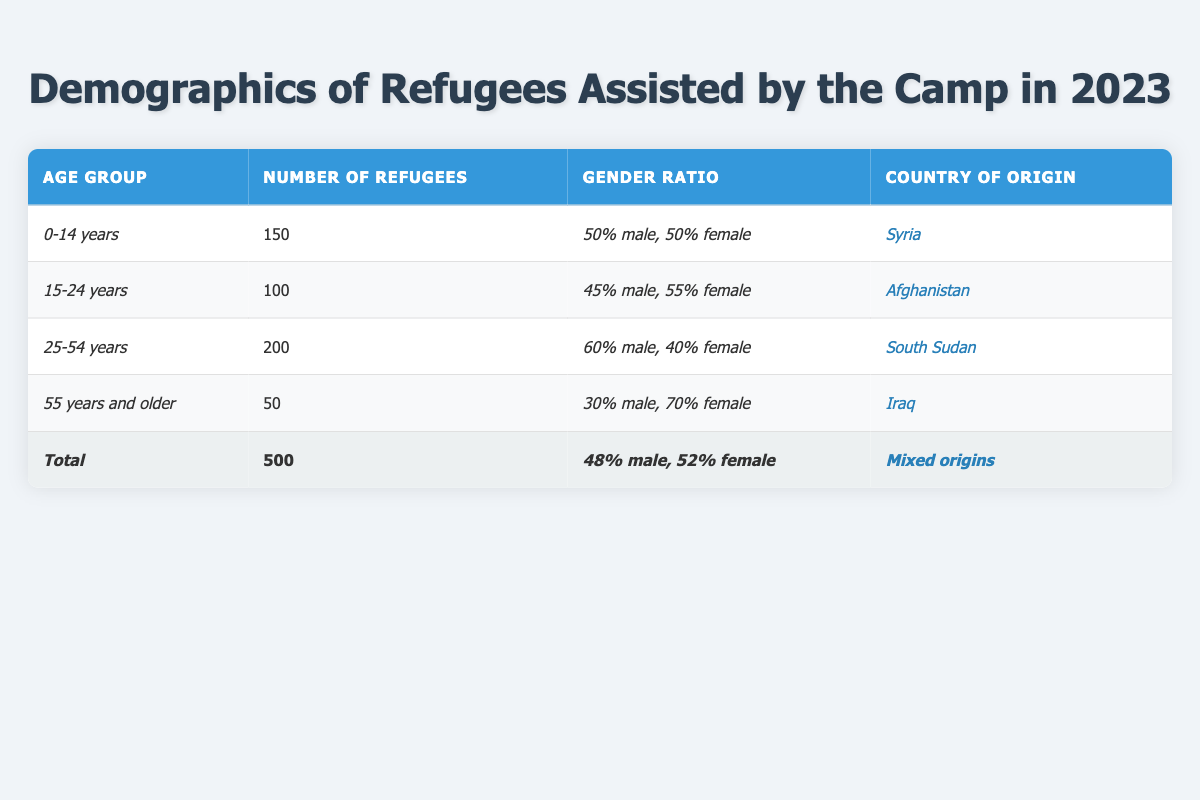What is the total number of refugees assisted by the camp in 2023? The table lists a row for the total number of refugees, which shows that there are 500 refugees assisted.
Answer: 500 Which age group has the highest number of refugees? By comparing the numbers for each age group, the 25-54 years age group has the highest total with 200 refugees.
Answer: 25-54 years What is the gender ratio for refugees aged 55 years and older? The table indicates that for the 55 years and older age group, the gender ratio is 30% male and 70% female.
Answer: 30% male, 70% female How many refugees from Afghanistan are in the 15-24 years age group? The table specifically states that there are 100 refugees from Afghanistan in the 15-24 years age group.
Answer: 100 What is the average number of refugees across all age groups? To find the average, sum the number of refugees in each age group (150 + 100 + 200 + 50) = 500, and divide by 4 (the number of age groups) which equals 125.
Answer: 125 Is the gender ratio predominantly female in the total number of refugees? The total gender ratio is shown as 48% male and 52% female, which indicates that females represent a larger percentage.
Answer: Yes What age group has the lowest representation in terms of the number of refugees? By reviewing the numbers, the 55 years and older age group has the lowest representation with only 50 refugees.
Answer: 55 years and older What is the combined number of male and female refugees in the 0-14 years age group? In the 0-14 years group, the number of refugees is given as 150, with an equal gender ratio, which means there are 75 males and 75 females. Adding these together gives 150.
Answer: 150 How does the total number of refugees compare between the youth category (0-24 years) and the adult category (25-54 years)? The youth category (0-14 + 15-24) totals 250 refugees (150 + 100) while the adult category (25-54) totals 200. Therefore, the youth category has more refugees.
Answer: Youth category is higher Is there a significant difference in the gender ratios between the 25-54 years group and the 55 years and older group? The gender ratio for 25-54 years is 60% male and 40% female, and for 55 years and older it is 30% male and 70% female, which shows a significant difference with a higher proportion of males in the younger group and vice versa.
Answer: Yes 